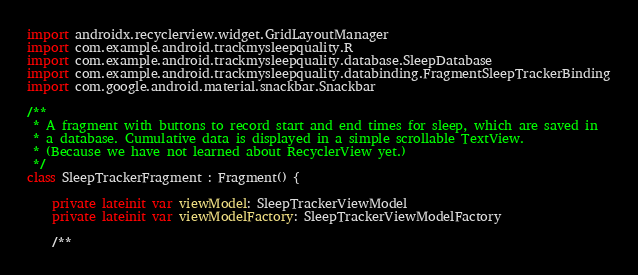<code> <loc_0><loc_0><loc_500><loc_500><_Kotlin_>import androidx.recyclerview.widget.GridLayoutManager
import com.example.android.trackmysleepquality.R
import com.example.android.trackmysleepquality.database.SleepDatabase
import com.example.android.trackmysleepquality.databinding.FragmentSleepTrackerBinding
import com.google.android.material.snackbar.Snackbar

/**
 * A fragment with buttons to record start and end times for sleep, which are saved in
 * a database. Cumulative data is displayed in a simple scrollable TextView.
 * (Because we have not learned about RecyclerView yet.)
 */
class SleepTrackerFragment : Fragment() {

    private lateinit var viewModel: SleepTrackerViewModel
    private lateinit var viewModelFactory: SleepTrackerViewModelFactory

    /**</code> 